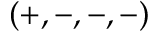Convert formula to latex. <formula><loc_0><loc_0><loc_500><loc_500>( + , - , - , - )</formula> 